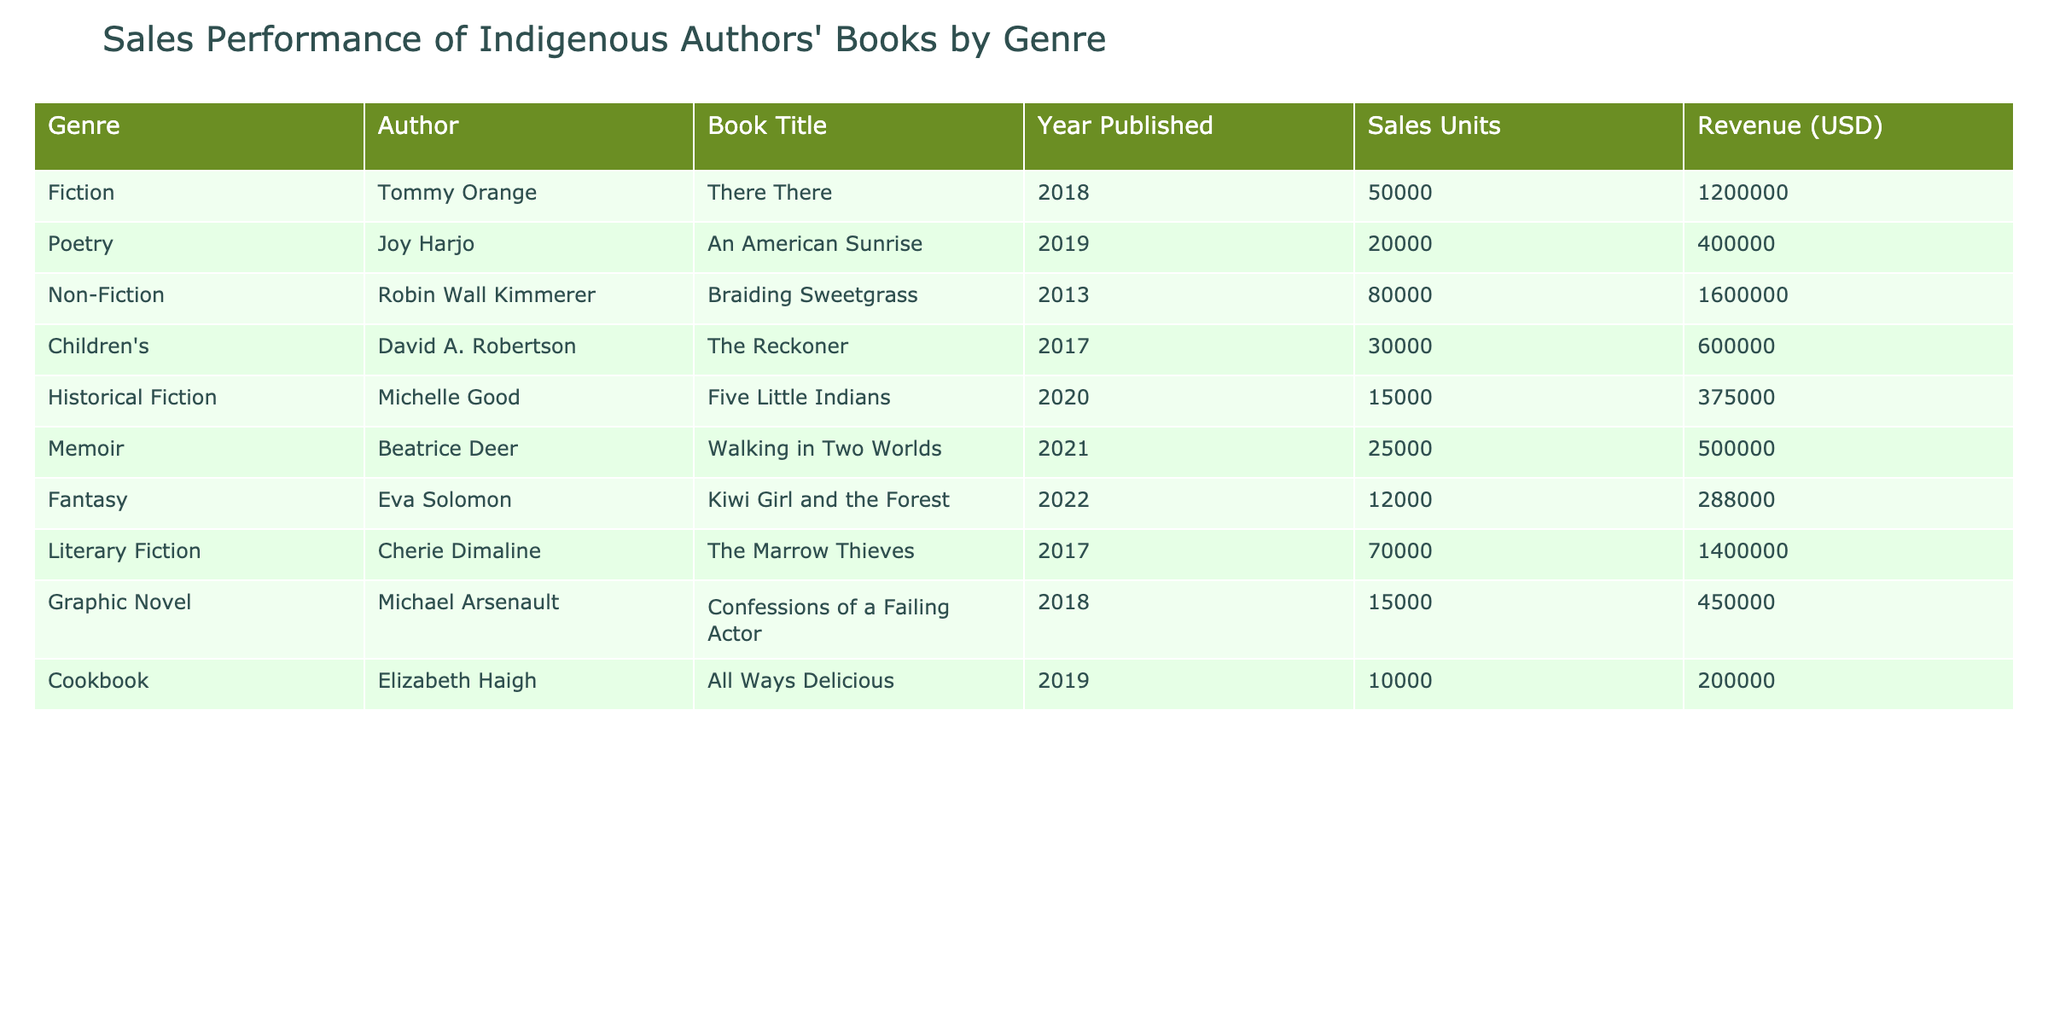What is the total revenue generated by all the books listed? To find the total revenue, we add up the revenue for each book: 1200000 (There There) + 400000 (An American Sunrise) + 1600000 (Braiding Sweetgrass) + 600000 (The Reckoner) + 375000 (Five Little Indians) + 500000 (Walking in Two Worlds) + 288000 (Kiwi Girl and the Forest) + 1400000 (The Marrow Thieves) + 450000 (Confessions of a Failing Actor) + 200000 (All Ways Delicious) =  4200000.
Answer: 4200000 Which author has the highest sales units for their book? Looking at the Sales Units column, Tommy Orange's book "There There" has 50000 units sold, which is the highest compared to all other authors' books in the list.
Answer: Tommy Orange What is the average sales units of the books in the Fiction genre? The Fiction genre has one entry, which is "There There" with 50000 units sold. Since there's only one book, the average sales units is the same as the sales units, which is 50000.
Answer: 50000 Did any authors achieve sales units of less than 20000? A quick review of the Sales Units column shows that Eva Solomon's "Kiwi Girl and the Forest" has 12000 sales units, which is less than 20000. Therefore, the answer is yes.
Answer: Yes What is the revenue difference between the highest and lowest revenue book in the table? The highest revenue is from "Braiding Sweetgrass" with 1600000, and the lowest is "All Ways Delicious" with 200000. To find the difference, we calculate 1600000 - 200000 = 1400000.
Answer: 1400000 What percentage of total sales units is contributed by the Non-Fiction books? The Non-Fiction book "Braiding Sweetgrass" has 80000 sales units. The total sales units across all books is 50000 + 20000 + 80000 + 30000 + 15000 + 25000 + 12000 + 70000 + 15000 + 10000 = 193000. So, the percentage is (80000 / 193000) * 100 = approximately 41.5%.
Answer: 41.5% Which genre contributes the highest revenue, based on the data? To determine the genre with the highest revenue, we examine the Revenue column: Fiction (1200000), Poetry (400000), Non-Fiction (1600000), Children's (600000), Historical Fiction (375000), Memoir (500000), Fantasy (288000), Literary Fiction (1400000), Graphic Novel (450000), and Cookbook (200000). The highest value is from Non-Fiction at 1600000.
Answer: Non-Fiction Is there any author who has books in multiple genres on the list? None of the authors listed have books that fall into more than one genre. Each author is associated with only one genre according to the table provided.
Answer: No 